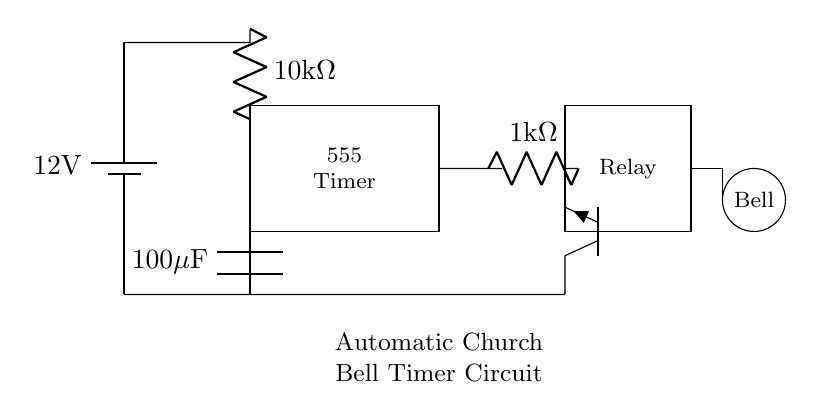What type of timer is used in this circuit? The circuit utilizes a 555 timer, which is a popular integrated circuit used for generating precise timing and oscillation. It is shown in the diagram as a rectangle labeled "555 Timer."
Answer: 555 timer What is the resistance value of the resistor connected to the 555 timer? The resistor connected to the 555 timer has a value of 10 kilohms, as indicated by the label on the resistor in the diagram.
Answer: 10 kilohms How many capacitors are in this circuit? The circuit contains one capacitor, which is labeled as a 100 microfarad capacitor. It is connected between the 555 timer and ground.
Answer: One What type of transistor is used in this circuit? The diagram shows an NPN transistor, indicated by the symbol for the transistor with a label "Tnpn." It plays a role in controlling the relay.
Answer: NPN What component is used to activate the church bell? The circuit activates the church bell through a relay, as depicted by the rectangle labeled "Relay." The relay is controlled by the output of the 555 timer.
Answer: Relay What is the supply voltage for the circuit? The supply voltage for this circuit is 12 volts, as indicated by the battery symbol labeled with "12 V" at the top left of the diagram.
Answer: 12 volts What is the total resistance in series with the relay? In series with the relay, there is a 1 kilohm resistor connected. This is the only resistor directly in series before the relay, totaling 1 kilohm.
Answer: 1 kilohm 